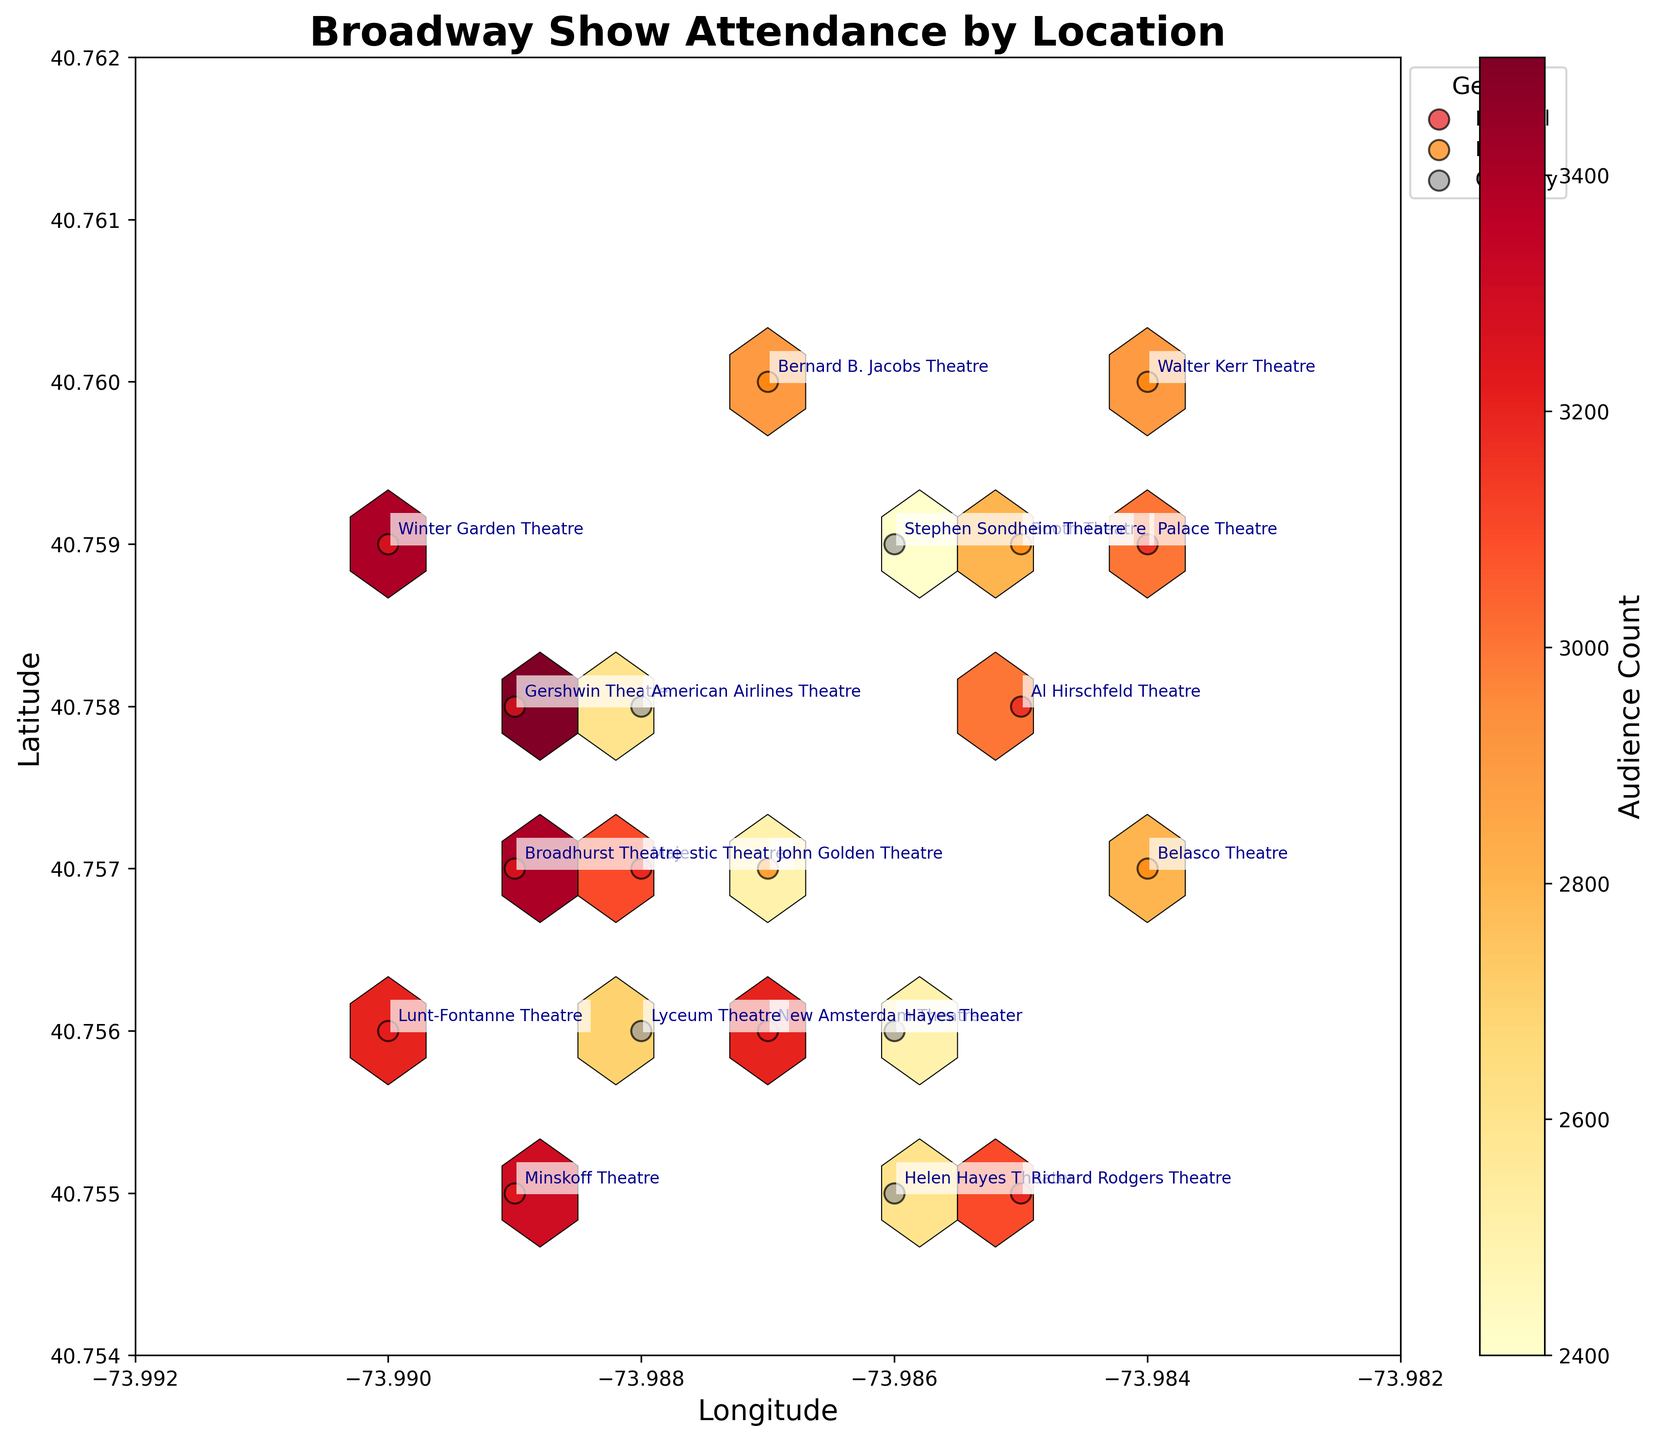What is the title of the hexbin plot? The title is usually placed at the top of the chart. The title in this figure is "Broadway Show Attendance by Location."
Answer: Broadway Show Attendance by Location What are the axis labels on the plot? Axis labels denote the information presented on each axis. This hexbin plot has "Longitude" on the x-axis and "Latitude" on the y-axis.
Answer: Longitude, Latitude Which theater has the highest audience count? Using the annotations, look for the theater with the highest value in the "Audience Count" color scale. The Gershwin Theatre has the highest count at 3500.
Answer: Gershwin Theatre What colors are used to represent the audience count? The hexbin plot uses a colormap to denote different audience counts, primarily ranging from yellow to red, indicating lower to higher counts.
Answer: Yellow to red How many unique genres are displayed in the legend? The legend indicates the genres present, which are marked by different colors and labels. There are three genres: Musical, Drama, and Comedy.
Answer: Three Which genre has the highest density around a specific location? By examining the density of hexagons and their color intensity, the "Musical" genre has the highest density, indicating large audience numbers around certain locations.
Answer: Musical Which theater is closest to the latitude of 40.759 and longitude -73.988? Based on the scatter plot markers and their corresponding annotations, the Majestic Theatre is closest to this coordinate.
Answer: Majestic Theatre Compare the audience count between the Gershwin Theatre and the New Amsterdam Theatre. Which one has a higher count? Refer to the annotations for both theaters and compare their audience counts. Gershwin Theatre has 3500 while New Amsterdam Theatre has 3200.
Answer: Gershwin Theatre What genre has the highest audience count in the Helen Hayes Theater? By checking the annotations and the scatter colors associated with this theater, which is categorized under "Comedy," and confirming its audience count.
Answer: Comedy How does the attendance in the Gershwin Theatre compare to the Stephen Sondheim Theatre? Compare the audience counts in the annotations: Gershwin Theatre has 3500, while Stephen Sondheim Theatre has 2400. Thus, the Gershwin Theatre has a higher attendance.
Answer: Gershwin Theatre 